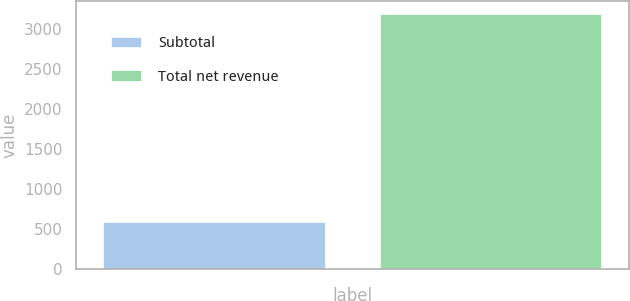Convert chart to OTSL. <chart><loc_0><loc_0><loc_500><loc_500><bar_chart><fcel>Subtotal<fcel>Total net revenue<nl><fcel>578.8<fcel>3182.5<nl></chart> 